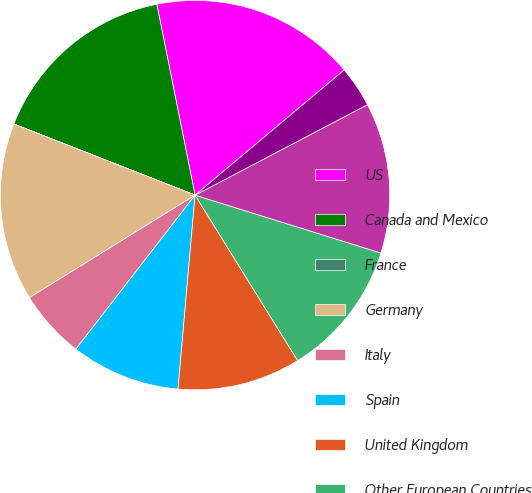Convert chart. <chart><loc_0><loc_0><loc_500><loc_500><pie_chart><fcel>US<fcel>Canada and Mexico<fcel>France<fcel>Germany<fcel>Italy<fcel>Spain<fcel>United Kingdom<fcel>Other European Countries<fcel>Korea<fcel>Thailand<nl><fcel>17.04%<fcel>15.9%<fcel>0.01%<fcel>14.77%<fcel>5.69%<fcel>9.09%<fcel>10.23%<fcel>11.36%<fcel>12.5%<fcel>3.42%<nl></chart> 